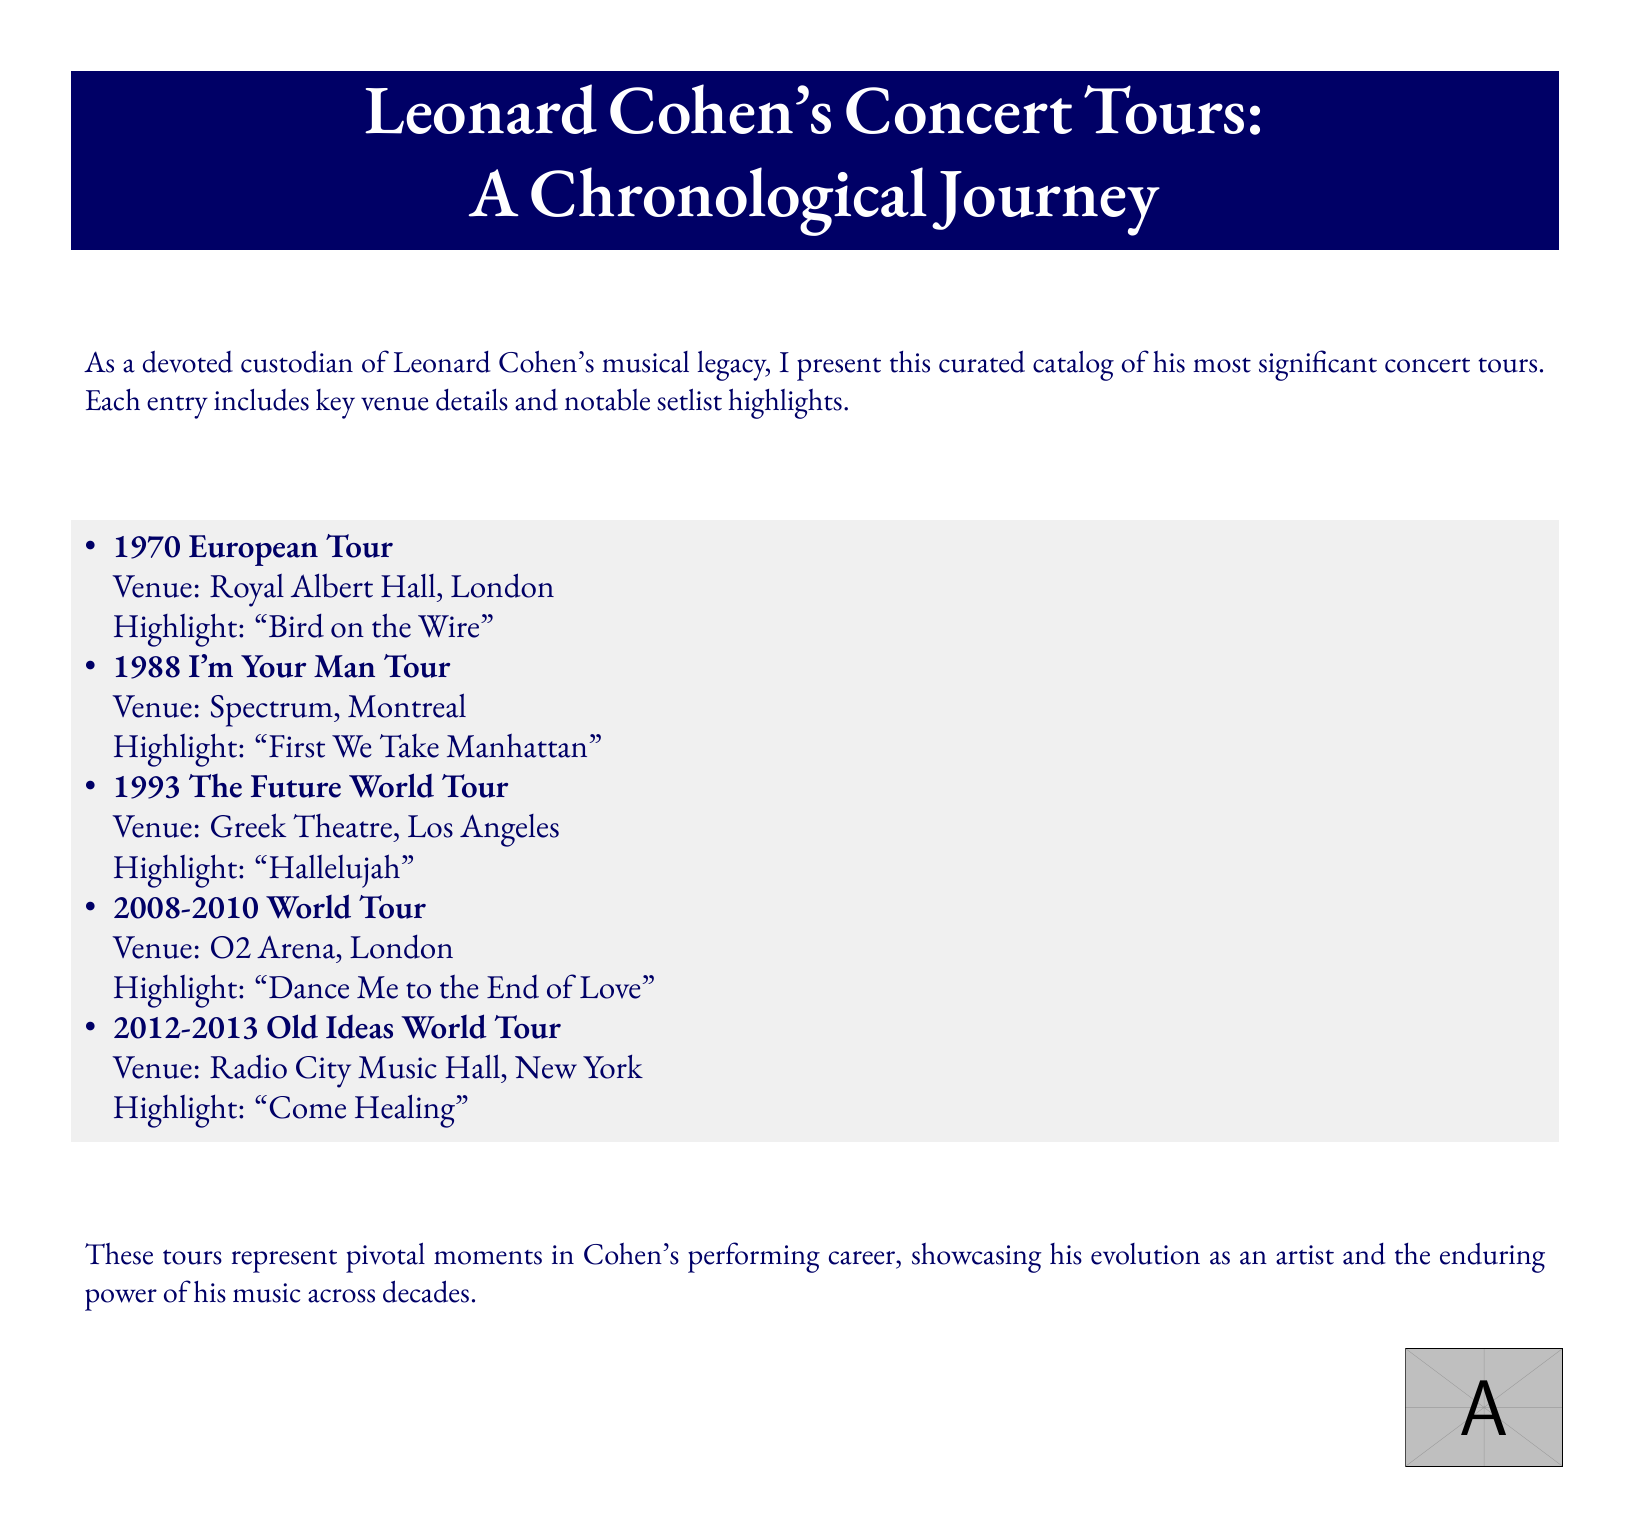what was the first concert tour listed? The first concert tour mentioned is the 1970 European Tour.
Answer: 1970 European Tour which venue is associated with the 1988 I'm Your Man Tour? The venue listed for the 1988 I'm Your Man Tour is Spectrum, Montreal.
Answer: Spectrum, Montreal how many concert tours are documented in total? The document lists five concert tours in total.
Answer: 5 which song is highlighted in the 1993 The Future World Tour? The highlighted song for the 1993 The Future World Tour is "Hallelujah."
Answer: Hallelujah where did the 2008-2010 World Tour take place? The 2008-2010 World Tour took place at O2 Arena, London.
Answer: O2 Arena, London what year range does the Old Ideas World Tour cover? The Old Ideas World Tour spans from 2012 to 2013.
Answer: 2012-2013 which highlight song is associated with the Royal Albert Hall venue? The highlight song associated with Royal Albert Hall is "Bird on the Wire."
Answer: Bird on the Wire what format is used to present the concert tour details? The concert tour details are presented in a chronological format.
Answer: chronological who is the subject of the concert tour catalog? The subject of the catalog is Leonard Cohen.
Answer: Leonard Cohen 